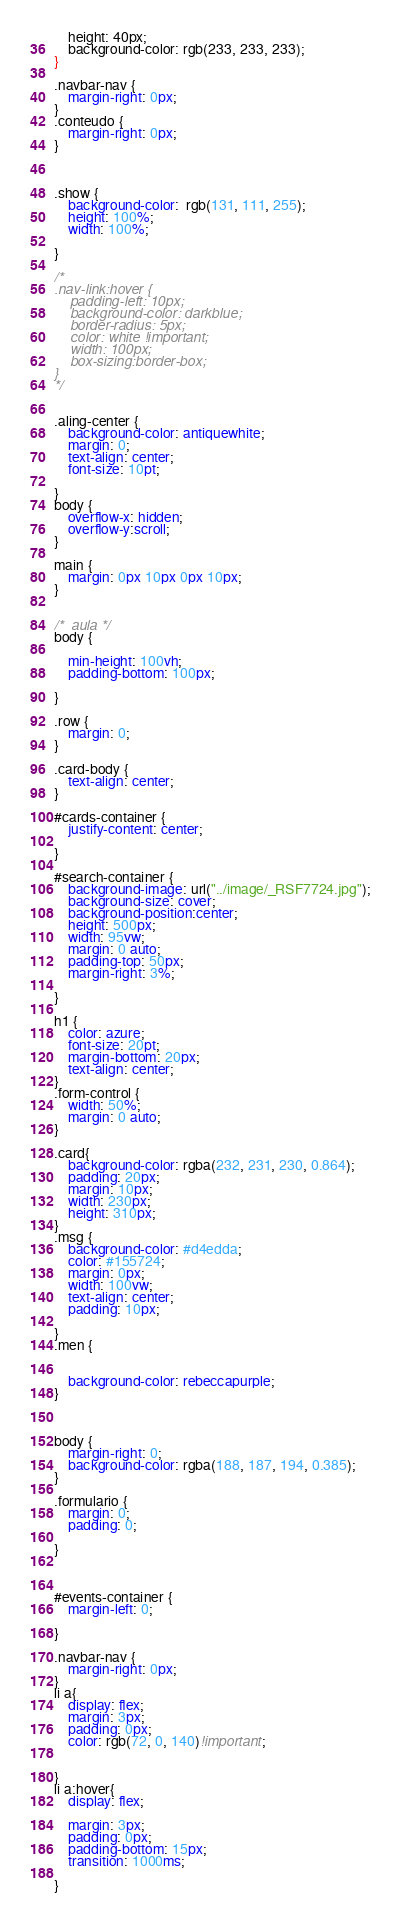<code> <loc_0><loc_0><loc_500><loc_500><_CSS_>    height: 40px;
    background-color: rgb(233, 233, 233);
}

.navbar-nav {
    margin-right: 0px;
}
.conteudo {
    margin-right: 0px;
}



.show {
    background-color:  rgb(131, 111, 255);
    height: 100%;
    width: 100%;
    
}

/*
.nav-link:hover {
    padding-left: 10px;
    background-color: darkblue;
    border-radius: 5px;
    color: white !important;
    width: 100px;
    box-sizing:border-box;
}
*/


.aling-center {
    background-color: antiquewhite;
    margin: 0;
    text-align: center;
    font-size: 10pt;
   
}
body {
    overflow-x: hidden;
    overflow-y:scroll;
}

main {
    margin: 0px 10px 0px 10px;
}


/*  aula */
body {

    min-height: 100vh;
    padding-bottom: 100px;
    
}

.row {
    margin: 0;
}

.card-body {
    text-align: center;
}

#cards-container {
    justify-content: center;
    
}

#search-container {
    background-image: url("../image/_RSF7724.jpg");
    background-size: cover;
    background-position:center;
    height: 500px;
    width: 95vw;
    margin: 0 auto;
    padding-top: 50px;
    margin-right: 3%;

}

h1 {
    color: azure;
    font-size: 20pt;
    margin-bottom: 20px;
    text-align: center;
}
.form-control {
    width: 50%;
    margin: 0 auto;
}

.card{
    background-color: rgba(232, 231, 230, 0.864);
    padding: 20px;
    margin: 10px;
    width: 230px;
    height: 310px;
}
.msg {
    background-color: #d4edda;
    color: #155724;
    margin: 0px;
    width: 100vw;
    text-align: center;
    padding: 10px;
    
}
.men {
    

    background-color: rebeccapurple;
}



body {
    margin-right: 0;
    background-color: rgba(188, 187, 194, 0.385);
}

.formulario {
    margin: 0;
    padding: 0;
    
}



#events-container {
    margin-left: 0;
    
}

.navbar-nav {
    margin-right: 0px;
}
li a{
    display: flex;
    margin: 3px;
    padding: 0px;
    color: rgb(72, 0, 140)!important;
   
  
}
li a:hover{
    display: flex;
    
    margin: 3px;
    padding: 0px;
    padding-bottom: 15px;
    transition: 1000ms;
    
}

</code> 